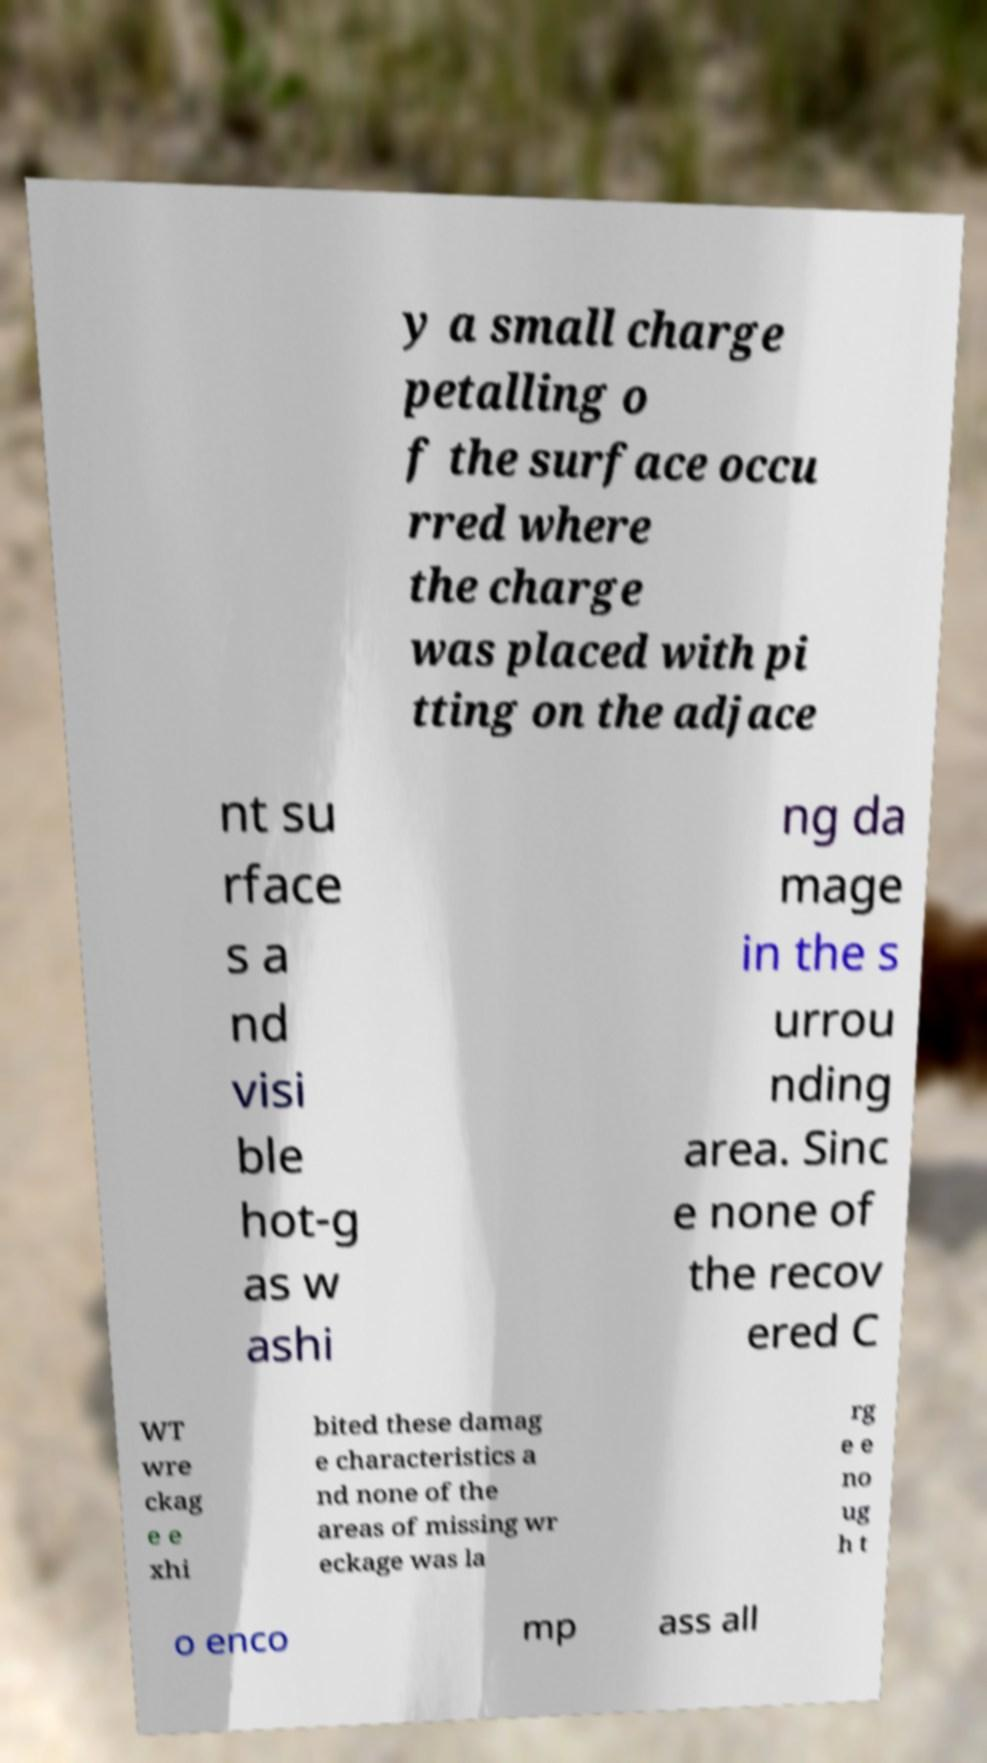For documentation purposes, I need the text within this image transcribed. Could you provide that? y a small charge petalling o f the surface occu rred where the charge was placed with pi tting on the adjace nt su rface s a nd visi ble hot-g as w ashi ng da mage in the s urrou nding area. Sinc e none of the recov ered C WT wre ckag e e xhi bited these damag e characteristics a nd none of the areas of missing wr eckage was la rg e e no ug h t o enco mp ass all 